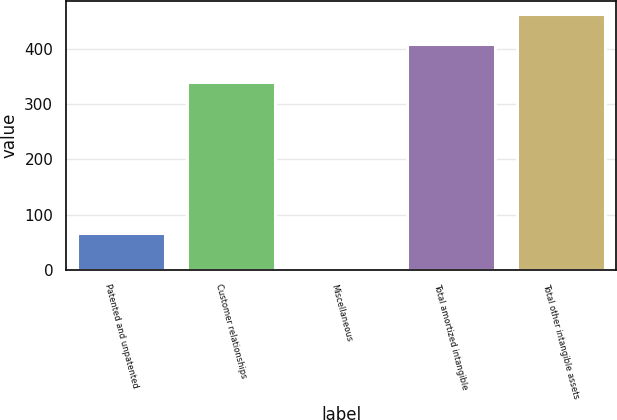<chart> <loc_0><loc_0><loc_500><loc_500><bar_chart><fcel>Patented and unpatented<fcel>Customer relationships<fcel>Miscellaneous<fcel>Total amortized intangible<fcel>Total other intangible assets<nl><fcel>66.6<fcel>340.2<fcel>1.9<fcel>408.7<fcel>463.5<nl></chart> 